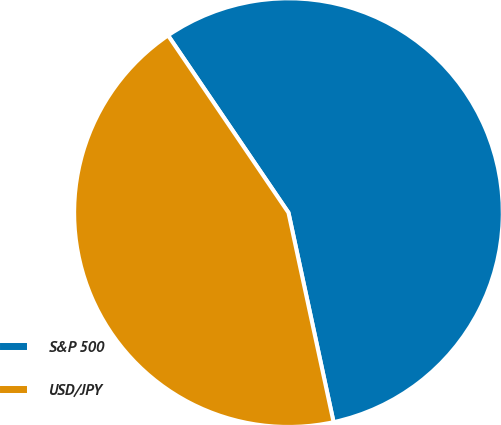Convert chart to OTSL. <chart><loc_0><loc_0><loc_500><loc_500><pie_chart><fcel>S&P 500<fcel>USD/JPY<nl><fcel>56.12%<fcel>43.88%<nl></chart> 